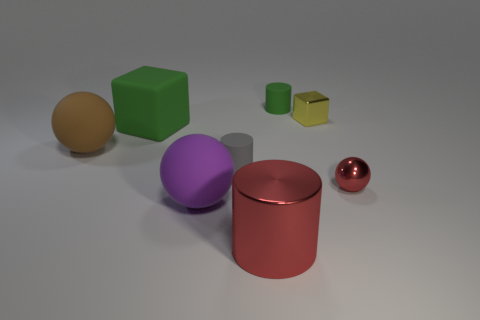Subtract all big rubber spheres. How many spheres are left? 1 Add 1 tiny cyan cylinders. How many objects exist? 9 Subtract all cylinders. How many objects are left? 5 Add 7 red spheres. How many red spheres are left? 8 Add 8 small yellow metal objects. How many small yellow metal objects exist? 9 Subtract 1 brown spheres. How many objects are left? 7 Subtract all yellow things. Subtract all balls. How many objects are left? 4 